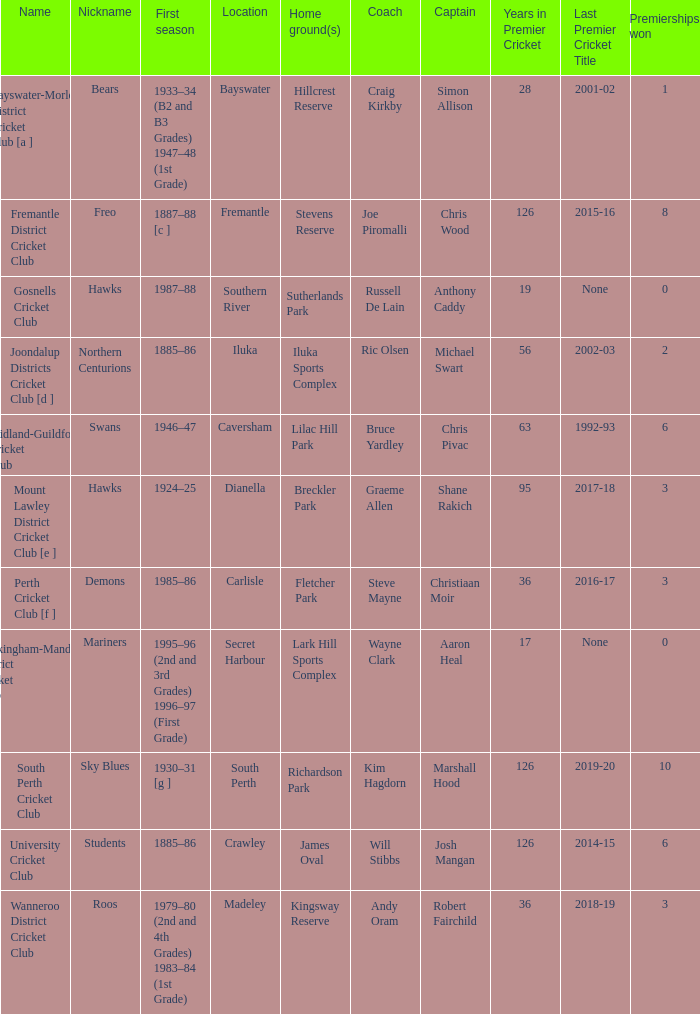What is the dates where Hillcrest Reserve is the home grounds? 1933–34 (B2 and B3 Grades) 1947–48 (1st Grade). Could you parse the entire table? {'header': ['Name', 'Nickname', 'First season', 'Location', 'Home ground(s)', 'Coach', 'Captain', 'Years in Premier Cricket', 'Last Premier Cricket Title', 'Premierships won'], 'rows': [['Bayswater-Morley District Cricket Club [a ]', 'Bears', '1933–34 (B2 and B3 Grades) 1947–48 (1st Grade)', 'Bayswater', 'Hillcrest Reserve', 'Craig Kirkby', 'Simon Allison', '28', '2001-02', '1'], ['Fremantle District Cricket Club', 'Freo', '1887–88 [c ]', 'Fremantle', 'Stevens Reserve', 'Joe Piromalli', 'Chris Wood', '126', '2015-16', '8'], ['Gosnells Cricket Club', 'Hawks', '1987–88', 'Southern River', 'Sutherlands Park', 'Russell De Lain', 'Anthony Caddy', '19', 'None', '0'], ['Joondalup Districts Cricket Club [d ]', 'Northern Centurions', '1885–86', 'Iluka', 'Iluka Sports Complex', 'Ric Olsen', 'Michael Swart', '56', '2002-03', '2'], ['Midland-Guildford Cricket Club', 'Swans', '1946–47', 'Caversham', 'Lilac Hill Park', 'Bruce Yardley', 'Chris Pivac', '63', '1992-93', '6'], ['Mount Lawley District Cricket Club [e ]', 'Hawks', '1924–25', 'Dianella', 'Breckler Park', 'Graeme Allen', 'Shane Rakich', '95', '2017-18', '3'], ['Perth Cricket Club [f ]', 'Demons', '1985–86', 'Carlisle', 'Fletcher Park', 'Steve Mayne', 'Christiaan Moir', '36', '2016-17', '3'], ['Rockingham-Mandurah District Cricket Club', 'Mariners', '1995–96 (2nd and 3rd Grades) 1996–97 (First Grade)', 'Secret Harbour', 'Lark Hill Sports Complex', 'Wayne Clark', 'Aaron Heal', '17', 'None', '0'], ['South Perth Cricket Club', 'Sky Blues', '1930–31 [g ]', 'South Perth', 'Richardson Park', 'Kim Hagdorn', 'Marshall Hood', '126', '2019-20', '10'], ['University Cricket Club', 'Students', '1885–86', 'Crawley', 'James Oval', 'Will Stibbs', 'Josh Mangan', '126', '2014-15', '6'], ['Wanneroo District Cricket Club', 'Roos', '1979–80 (2nd and 4th Grades) 1983–84 (1st Grade)', 'Madeley', 'Kingsway Reserve', 'Andy Oram', 'Robert Fairchild', '36', '2018-19', '3']]} 